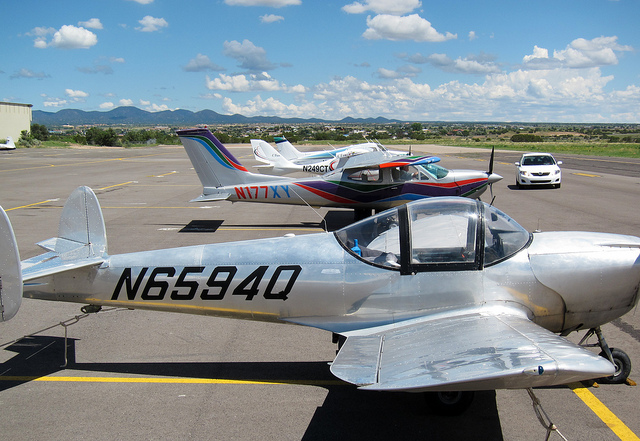Can you tell me more about the plane in the foreground? The aircraft in the foreground appears to be a small, single-engine, propeller-driven plane, possibly used for personal travel or instruction. Its polished metal exterior and streamlined design suggest it may be a vintage or custom-made aircraft, reflecting a classic aviation style. 